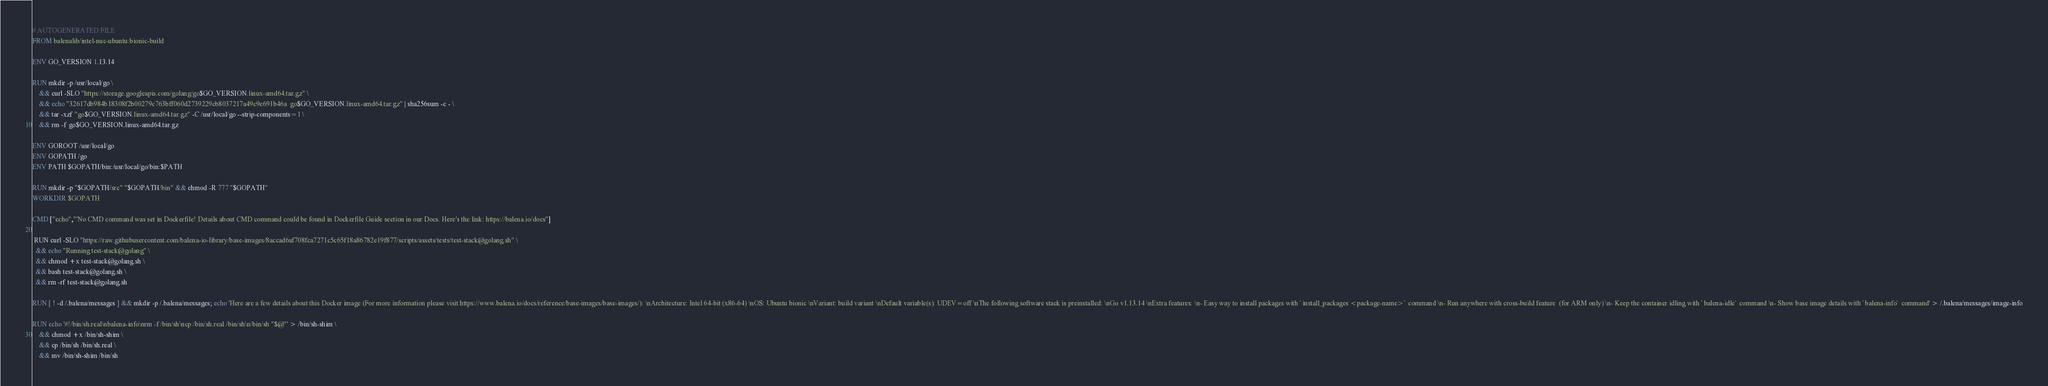<code> <loc_0><loc_0><loc_500><loc_500><_Dockerfile_># AUTOGENERATED FILE
FROM balenalib/intel-nuc-ubuntu:bionic-build

ENV GO_VERSION 1.13.14

RUN mkdir -p /usr/local/go \
	&& curl -SLO "https://storage.googleapis.com/golang/go$GO_VERSION.linux-amd64.tar.gz" \
	&& echo "32617db984b18308f2b00279c763bff060d2739229cb8037217a49c9e691b46a  go$GO_VERSION.linux-amd64.tar.gz" | sha256sum -c - \
	&& tar -xzf "go$GO_VERSION.linux-amd64.tar.gz" -C /usr/local/go --strip-components=1 \
	&& rm -f go$GO_VERSION.linux-amd64.tar.gz

ENV GOROOT /usr/local/go
ENV GOPATH /go
ENV PATH $GOPATH/bin:/usr/local/go/bin:$PATH

RUN mkdir -p "$GOPATH/src" "$GOPATH/bin" && chmod -R 777 "$GOPATH"
WORKDIR $GOPATH

CMD ["echo","'No CMD command was set in Dockerfile! Details about CMD command could be found in Dockerfile Guide section in our Docs. Here's the link: https://balena.io/docs"]

 RUN curl -SLO "https://raw.githubusercontent.com/balena-io-library/base-images/8accad6af708fca7271c5c65f18a86782e19f877/scripts/assets/tests/test-stack@golang.sh" \
  && echo "Running test-stack@golang" \
  && chmod +x test-stack@golang.sh \
  && bash test-stack@golang.sh \
  && rm -rf test-stack@golang.sh 

RUN [ ! -d /.balena/messages ] && mkdir -p /.balena/messages; echo 'Here are a few details about this Docker image (For more information please visit https://www.balena.io/docs/reference/base-images/base-images/): \nArchitecture: Intel 64-bit (x86-64) \nOS: Ubuntu bionic \nVariant: build variant \nDefault variable(s): UDEV=off \nThe following software stack is preinstalled: \nGo v1.13.14 \nExtra features: \n- Easy way to install packages with `install_packages <package-name>` command \n- Run anywhere with cross-build feature  (for ARM only) \n- Keep the container idling with `balena-idle` command \n- Show base image details with `balena-info` command' > /.balena/messages/image-info

RUN echo '#!/bin/sh.real\nbalena-info\nrm -f /bin/sh\ncp /bin/sh.real /bin/sh\n/bin/sh "$@"' > /bin/sh-shim \
	&& chmod +x /bin/sh-shim \
	&& cp /bin/sh /bin/sh.real \
	&& mv /bin/sh-shim /bin/sh</code> 